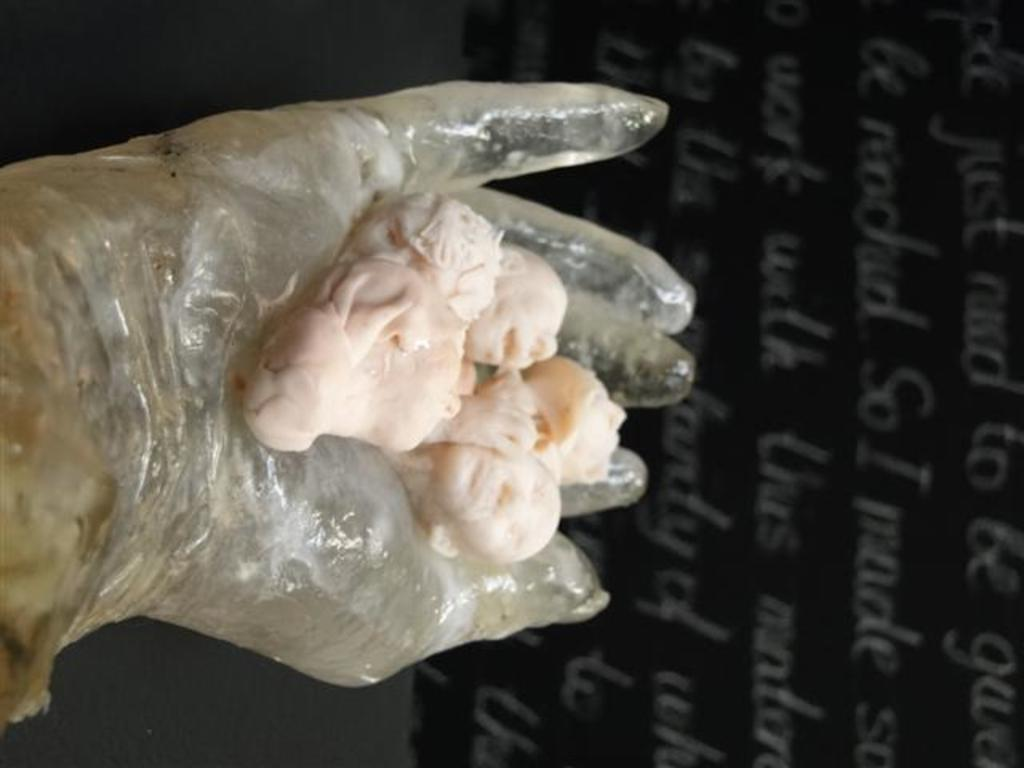What is on the person's hand in the image? There are sculptures on the person's hand in the image. What is the person wearing on their hand? The person is wearing a glove. What can be seen in the background of the image? There is a board with text in the background of the image. Can you hear the stranger laughing in the image? There is no stranger or laughter present in the image; it only features a person with sculptures on their hand and a board with text in the background. 